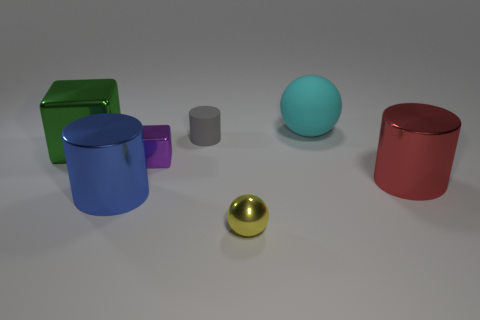Is the size of the yellow metallic ball the same as the gray rubber object?
Provide a short and direct response. Yes. The big thing behind the large green shiny object is what color?
Your answer should be very brief. Cyan. Are there any big rubber cylinders of the same color as the small metallic block?
Provide a short and direct response. No. What color is the rubber object that is the same size as the blue shiny thing?
Provide a succinct answer. Cyan. Does the gray rubber object have the same shape as the small yellow metal thing?
Your answer should be very brief. No. There is a sphere behind the red cylinder; what material is it?
Your answer should be compact. Rubber. The small cylinder is what color?
Keep it short and to the point. Gray. There is a metal object behind the small purple object; is it the same size as the shiny object to the right of the yellow shiny object?
Provide a succinct answer. Yes. How big is the metal object that is in front of the large red cylinder and to the right of the tiny gray matte object?
Your answer should be very brief. Small. What color is the other large thing that is the same shape as the purple object?
Give a very brief answer. Green. 